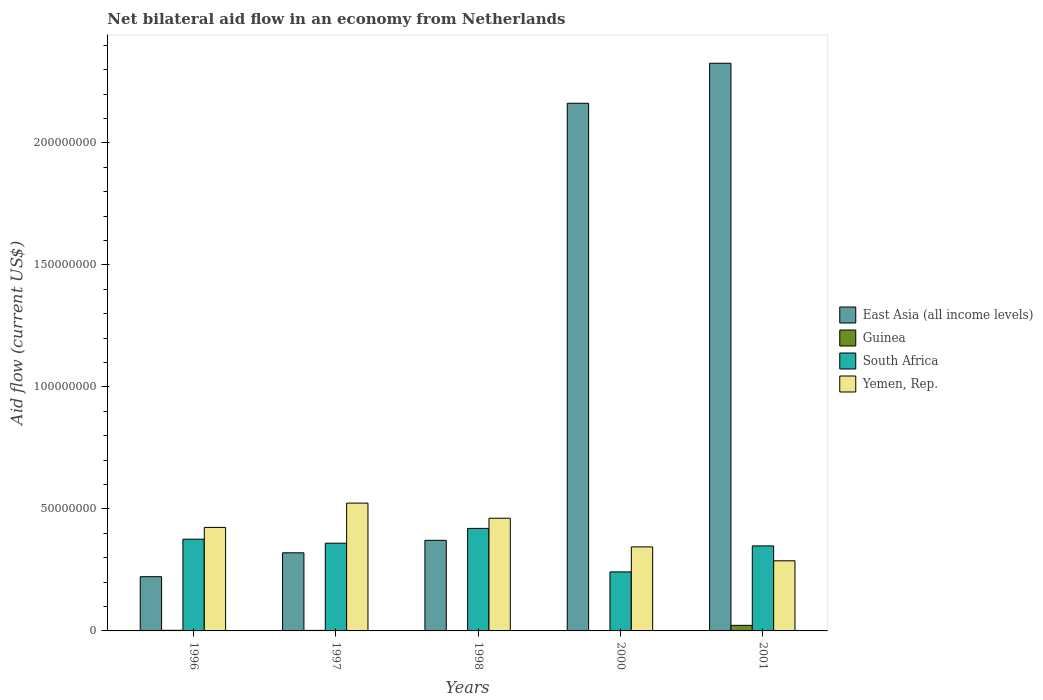Are the number of bars per tick equal to the number of legend labels?
Keep it short and to the point. Yes. How many bars are there on the 3rd tick from the right?
Your answer should be very brief. 4. In how many cases, is the number of bars for a given year not equal to the number of legend labels?
Ensure brevity in your answer.  0. What is the net bilateral aid flow in East Asia (all income levels) in 1998?
Provide a short and direct response. 3.71e+07. Across all years, what is the maximum net bilateral aid flow in South Africa?
Offer a terse response. 4.20e+07. Across all years, what is the minimum net bilateral aid flow in South Africa?
Ensure brevity in your answer.  2.42e+07. In which year was the net bilateral aid flow in South Africa minimum?
Provide a short and direct response. 2000. What is the total net bilateral aid flow in South Africa in the graph?
Your response must be concise. 1.75e+08. What is the difference between the net bilateral aid flow in Guinea in 1998 and that in 2000?
Your answer should be very brief. 7.00e+04. What is the difference between the net bilateral aid flow in Guinea in 2000 and the net bilateral aid flow in Yemen, Rep. in 2001?
Give a very brief answer. -2.87e+07. What is the average net bilateral aid flow in Yemen, Rep. per year?
Provide a short and direct response. 4.08e+07. In the year 2000, what is the difference between the net bilateral aid flow in South Africa and net bilateral aid flow in East Asia (all income levels)?
Keep it short and to the point. -1.92e+08. What is the ratio of the net bilateral aid flow in East Asia (all income levels) in 1998 to that in 2000?
Provide a short and direct response. 0.17. Is the net bilateral aid flow in South Africa in 1996 less than that in 2001?
Keep it short and to the point. No. What is the difference between the highest and the second highest net bilateral aid flow in East Asia (all income levels)?
Offer a terse response. 1.64e+07. What is the difference between the highest and the lowest net bilateral aid flow in South Africa?
Your answer should be very brief. 1.78e+07. In how many years, is the net bilateral aid flow in South Africa greater than the average net bilateral aid flow in South Africa taken over all years?
Provide a succinct answer. 3. Is the sum of the net bilateral aid flow in East Asia (all income levels) in 1998 and 2001 greater than the maximum net bilateral aid flow in Guinea across all years?
Make the answer very short. Yes. What does the 1st bar from the left in 1996 represents?
Provide a succinct answer. East Asia (all income levels). What does the 1st bar from the right in 2001 represents?
Give a very brief answer. Yemen, Rep. Is it the case that in every year, the sum of the net bilateral aid flow in East Asia (all income levels) and net bilateral aid flow in Guinea is greater than the net bilateral aid flow in Yemen, Rep.?
Your answer should be compact. No. Are all the bars in the graph horizontal?
Your answer should be very brief. No. Are the values on the major ticks of Y-axis written in scientific E-notation?
Make the answer very short. No. Does the graph contain any zero values?
Offer a very short reply. No. Where does the legend appear in the graph?
Your answer should be compact. Center right. How many legend labels are there?
Provide a short and direct response. 4. What is the title of the graph?
Offer a very short reply. Net bilateral aid flow in an economy from Netherlands. Does "Italy" appear as one of the legend labels in the graph?
Offer a very short reply. No. What is the label or title of the Y-axis?
Keep it short and to the point. Aid flow (current US$). What is the Aid flow (current US$) in East Asia (all income levels) in 1996?
Make the answer very short. 2.22e+07. What is the Aid flow (current US$) in South Africa in 1996?
Your response must be concise. 3.76e+07. What is the Aid flow (current US$) in Yemen, Rep. in 1996?
Your response must be concise. 4.24e+07. What is the Aid flow (current US$) in East Asia (all income levels) in 1997?
Ensure brevity in your answer.  3.20e+07. What is the Aid flow (current US$) of Guinea in 1997?
Your answer should be compact. 2.20e+05. What is the Aid flow (current US$) in South Africa in 1997?
Ensure brevity in your answer.  3.59e+07. What is the Aid flow (current US$) of Yemen, Rep. in 1997?
Your answer should be very brief. 5.24e+07. What is the Aid flow (current US$) of East Asia (all income levels) in 1998?
Provide a succinct answer. 3.71e+07. What is the Aid flow (current US$) of South Africa in 1998?
Your answer should be compact. 4.20e+07. What is the Aid flow (current US$) in Yemen, Rep. in 1998?
Make the answer very short. 4.62e+07. What is the Aid flow (current US$) of East Asia (all income levels) in 2000?
Offer a terse response. 2.16e+08. What is the Aid flow (current US$) in Guinea in 2000?
Your answer should be compact. 2.00e+04. What is the Aid flow (current US$) in South Africa in 2000?
Ensure brevity in your answer.  2.42e+07. What is the Aid flow (current US$) of Yemen, Rep. in 2000?
Provide a succinct answer. 3.44e+07. What is the Aid flow (current US$) in East Asia (all income levels) in 2001?
Your answer should be compact. 2.33e+08. What is the Aid flow (current US$) in Guinea in 2001?
Keep it short and to the point. 2.28e+06. What is the Aid flow (current US$) of South Africa in 2001?
Give a very brief answer. 3.48e+07. What is the Aid flow (current US$) in Yemen, Rep. in 2001?
Your answer should be very brief. 2.87e+07. Across all years, what is the maximum Aid flow (current US$) in East Asia (all income levels)?
Provide a short and direct response. 2.33e+08. Across all years, what is the maximum Aid flow (current US$) in Guinea?
Give a very brief answer. 2.28e+06. Across all years, what is the maximum Aid flow (current US$) in South Africa?
Give a very brief answer. 4.20e+07. Across all years, what is the maximum Aid flow (current US$) in Yemen, Rep.?
Provide a succinct answer. 5.24e+07. Across all years, what is the minimum Aid flow (current US$) of East Asia (all income levels)?
Ensure brevity in your answer.  2.22e+07. Across all years, what is the minimum Aid flow (current US$) in Guinea?
Offer a very short reply. 2.00e+04. Across all years, what is the minimum Aid flow (current US$) of South Africa?
Offer a very short reply. 2.42e+07. Across all years, what is the minimum Aid flow (current US$) in Yemen, Rep.?
Your answer should be very brief. 2.87e+07. What is the total Aid flow (current US$) in East Asia (all income levels) in the graph?
Provide a succinct answer. 5.40e+08. What is the total Aid flow (current US$) in Guinea in the graph?
Your answer should be compact. 2.86e+06. What is the total Aid flow (current US$) of South Africa in the graph?
Offer a very short reply. 1.75e+08. What is the total Aid flow (current US$) of Yemen, Rep. in the graph?
Provide a short and direct response. 2.04e+08. What is the difference between the Aid flow (current US$) of East Asia (all income levels) in 1996 and that in 1997?
Offer a terse response. -9.79e+06. What is the difference between the Aid flow (current US$) in South Africa in 1996 and that in 1997?
Ensure brevity in your answer.  1.65e+06. What is the difference between the Aid flow (current US$) in Yemen, Rep. in 1996 and that in 1997?
Provide a succinct answer. -9.96e+06. What is the difference between the Aid flow (current US$) of East Asia (all income levels) in 1996 and that in 1998?
Offer a terse response. -1.49e+07. What is the difference between the Aid flow (current US$) in South Africa in 1996 and that in 1998?
Provide a succinct answer. -4.42e+06. What is the difference between the Aid flow (current US$) in Yemen, Rep. in 1996 and that in 1998?
Give a very brief answer. -3.76e+06. What is the difference between the Aid flow (current US$) of East Asia (all income levels) in 1996 and that in 2000?
Offer a very short reply. -1.94e+08. What is the difference between the Aid flow (current US$) in South Africa in 1996 and that in 2000?
Offer a very short reply. 1.34e+07. What is the difference between the Aid flow (current US$) of Yemen, Rep. in 1996 and that in 2000?
Give a very brief answer. 7.99e+06. What is the difference between the Aid flow (current US$) in East Asia (all income levels) in 1996 and that in 2001?
Offer a terse response. -2.10e+08. What is the difference between the Aid flow (current US$) in Guinea in 1996 and that in 2001?
Offer a very short reply. -2.03e+06. What is the difference between the Aid flow (current US$) of South Africa in 1996 and that in 2001?
Your answer should be compact. 2.75e+06. What is the difference between the Aid flow (current US$) of Yemen, Rep. in 1996 and that in 2001?
Give a very brief answer. 1.37e+07. What is the difference between the Aid flow (current US$) in East Asia (all income levels) in 1997 and that in 1998?
Your response must be concise. -5.12e+06. What is the difference between the Aid flow (current US$) in South Africa in 1997 and that in 1998?
Your answer should be very brief. -6.07e+06. What is the difference between the Aid flow (current US$) in Yemen, Rep. in 1997 and that in 1998?
Your response must be concise. 6.20e+06. What is the difference between the Aid flow (current US$) in East Asia (all income levels) in 1997 and that in 2000?
Your answer should be compact. -1.84e+08. What is the difference between the Aid flow (current US$) of Guinea in 1997 and that in 2000?
Provide a short and direct response. 2.00e+05. What is the difference between the Aid flow (current US$) in South Africa in 1997 and that in 2000?
Provide a short and direct response. 1.18e+07. What is the difference between the Aid flow (current US$) in Yemen, Rep. in 1997 and that in 2000?
Your response must be concise. 1.80e+07. What is the difference between the Aid flow (current US$) of East Asia (all income levels) in 1997 and that in 2001?
Offer a terse response. -2.01e+08. What is the difference between the Aid flow (current US$) in Guinea in 1997 and that in 2001?
Ensure brevity in your answer.  -2.06e+06. What is the difference between the Aid flow (current US$) of South Africa in 1997 and that in 2001?
Ensure brevity in your answer.  1.10e+06. What is the difference between the Aid flow (current US$) in Yemen, Rep. in 1997 and that in 2001?
Ensure brevity in your answer.  2.36e+07. What is the difference between the Aid flow (current US$) in East Asia (all income levels) in 1998 and that in 2000?
Keep it short and to the point. -1.79e+08. What is the difference between the Aid flow (current US$) in South Africa in 1998 and that in 2000?
Your answer should be compact. 1.78e+07. What is the difference between the Aid flow (current US$) in Yemen, Rep. in 1998 and that in 2000?
Make the answer very short. 1.18e+07. What is the difference between the Aid flow (current US$) of East Asia (all income levels) in 1998 and that in 2001?
Your answer should be very brief. -1.95e+08. What is the difference between the Aid flow (current US$) in Guinea in 1998 and that in 2001?
Provide a succinct answer. -2.19e+06. What is the difference between the Aid flow (current US$) in South Africa in 1998 and that in 2001?
Your answer should be compact. 7.17e+06. What is the difference between the Aid flow (current US$) in Yemen, Rep. in 1998 and that in 2001?
Make the answer very short. 1.74e+07. What is the difference between the Aid flow (current US$) in East Asia (all income levels) in 2000 and that in 2001?
Your answer should be compact. -1.64e+07. What is the difference between the Aid flow (current US$) in Guinea in 2000 and that in 2001?
Offer a terse response. -2.26e+06. What is the difference between the Aid flow (current US$) in South Africa in 2000 and that in 2001?
Provide a short and direct response. -1.07e+07. What is the difference between the Aid flow (current US$) of Yemen, Rep. in 2000 and that in 2001?
Offer a very short reply. 5.70e+06. What is the difference between the Aid flow (current US$) of East Asia (all income levels) in 1996 and the Aid flow (current US$) of Guinea in 1997?
Offer a very short reply. 2.20e+07. What is the difference between the Aid flow (current US$) of East Asia (all income levels) in 1996 and the Aid flow (current US$) of South Africa in 1997?
Your answer should be compact. -1.37e+07. What is the difference between the Aid flow (current US$) in East Asia (all income levels) in 1996 and the Aid flow (current US$) in Yemen, Rep. in 1997?
Offer a very short reply. -3.02e+07. What is the difference between the Aid flow (current US$) of Guinea in 1996 and the Aid flow (current US$) of South Africa in 1997?
Keep it short and to the point. -3.57e+07. What is the difference between the Aid flow (current US$) of Guinea in 1996 and the Aid flow (current US$) of Yemen, Rep. in 1997?
Keep it short and to the point. -5.21e+07. What is the difference between the Aid flow (current US$) of South Africa in 1996 and the Aid flow (current US$) of Yemen, Rep. in 1997?
Your answer should be compact. -1.48e+07. What is the difference between the Aid flow (current US$) in East Asia (all income levels) in 1996 and the Aid flow (current US$) in Guinea in 1998?
Provide a short and direct response. 2.21e+07. What is the difference between the Aid flow (current US$) in East Asia (all income levels) in 1996 and the Aid flow (current US$) in South Africa in 1998?
Provide a succinct answer. -1.98e+07. What is the difference between the Aid flow (current US$) in East Asia (all income levels) in 1996 and the Aid flow (current US$) in Yemen, Rep. in 1998?
Give a very brief answer. -2.40e+07. What is the difference between the Aid flow (current US$) of Guinea in 1996 and the Aid flow (current US$) of South Africa in 1998?
Your answer should be compact. -4.18e+07. What is the difference between the Aid flow (current US$) in Guinea in 1996 and the Aid flow (current US$) in Yemen, Rep. in 1998?
Your answer should be compact. -4.59e+07. What is the difference between the Aid flow (current US$) of South Africa in 1996 and the Aid flow (current US$) of Yemen, Rep. in 1998?
Ensure brevity in your answer.  -8.59e+06. What is the difference between the Aid flow (current US$) in East Asia (all income levels) in 1996 and the Aid flow (current US$) in Guinea in 2000?
Your response must be concise. 2.22e+07. What is the difference between the Aid flow (current US$) in East Asia (all income levels) in 1996 and the Aid flow (current US$) in South Africa in 2000?
Your answer should be compact. -1.96e+06. What is the difference between the Aid flow (current US$) in East Asia (all income levels) in 1996 and the Aid flow (current US$) in Yemen, Rep. in 2000?
Ensure brevity in your answer.  -1.22e+07. What is the difference between the Aid flow (current US$) of Guinea in 1996 and the Aid flow (current US$) of South Africa in 2000?
Ensure brevity in your answer.  -2.39e+07. What is the difference between the Aid flow (current US$) of Guinea in 1996 and the Aid flow (current US$) of Yemen, Rep. in 2000?
Offer a terse response. -3.42e+07. What is the difference between the Aid flow (current US$) in South Africa in 1996 and the Aid flow (current US$) in Yemen, Rep. in 2000?
Your answer should be compact. 3.16e+06. What is the difference between the Aid flow (current US$) in East Asia (all income levels) in 1996 and the Aid flow (current US$) in Guinea in 2001?
Give a very brief answer. 1.99e+07. What is the difference between the Aid flow (current US$) in East Asia (all income levels) in 1996 and the Aid flow (current US$) in South Africa in 2001?
Your answer should be very brief. -1.26e+07. What is the difference between the Aid flow (current US$) of East Asia (all income levels) in 1996 and the Aid flow (current US$) of Yemen, Rep. in 2001?
Provide a short and direct response. -6.51e+06. What is the difference between the Aid flow (current US$) of Guinea in 1996 and the Aid flow (current US$) of South Africa in 2001?
Provide a short and direct response. -3.46e+07. What is the difference between the Aid flow (current US$) of Guinea in 1996 and the Aid flow (current US$) of Yemen, Rep. in 2001?
Offer a terse response. -2.85e+07. What is the difference between the Aid flow (current US$) in South Africa in 1996 and the Aid flow (current US$) in Yemen, Rep. in 2001?
Provide a succinct answer. 8.86e+06. What is the difference between the Aid flow (current US$) in East Asia (all income levels) in 1997 and the Aid flow (current US$) in Guinea in 1998?
Your answer should be very brief. 3.19e+07. What is the difference between the Aid flow (current US$) of East Asia (all income levels) in 1997 and the Aid flow (current US$) of South Africa in 1998?
Offer a very short reply. -1.00e+07. What is the difference between the Aid flow (current US$) of East Asia (all income levels) in 1997 and the Aid flow (current US$) of Yemen, Rep. in 1998?
Provide a short and direct response. -1.42e+07. What is the difference between the Aid flow (current US$) in Guinea in 1997 and the Aid flow (current US$) in South Africa in 1998?
Provide a short and direct response. -4.18e+07. What is the difference between the Aid flow (current US$) in Guinea in 1997 and the Aid flow (current US$) in Yemen, Rep. in 1998?
Provide a short and direct response. -4.60e+07. What is the difference between the Aid flow (current US$) in South Africa in 1997 and the Aid flow (current US$) in Yemen, Rep. in 1998?
Offer a very short reply. -1.02e+07. What is the difference between the Aid flow (current US$) of East Asia (all income levels) in 1997 and the Aid flow (current US$) of Guinea in 2000?
Give a very brief answer. 3.20e+07. What is the difference between the Aid flow (current US$) of East Asia (all income levels) in 1997 and the Aid flow (current US$) of South Africa in 2000?
Make the answer very short. 7.83e+06. What is the difference between the Aid flow (current US$) in East Asia (all income levels) in 1997 and the Aid flow (current US$) in Yemen, Rep. in 2000?
Ensure brevity in your answer.  -2.42e+06. What is the difference between the Aid flow (current US$) in Guinea in 1997 and the Aid flow (current US$) in South Africa in 2000?
Give a very brief answer. -2.40e+07. What is the difference between the Aid flow (current US$) of Guinea in 1997 and the Aid flow (current US$) of Yemen, Rep. in 2000?
Your answer should be very brief. -3.42e+07. What is the difference between the Aid flow (current US$) of South Africa in 1997 and the Aid flow (current US$) of Yemen, Rep. in 2000?
Your answer should be very brief. 1.51e+06. What is the difference between the Aid flow (current US$) in East Asia (all income levels) in 1997 and the Aid flow (current US$) in Guinea in 2001?
Give a very brief answer. 2.97e+07. What is the difference between the Aid flow (current US$) in East Asia (all income levels) in 1997 and the Aid flow (current US$) in South Africa in 2001?
Your answer should be very brief. -2.83e+06. What is the difference between the Aid flow (current US$) in East Asia (all income levels) in 1997 and the Aid flow (current US$) in Yemen, Rep. in 2001?
Give a very brief answer. 3.28e+06. What is the difference between the Aid flow (current US$) in Guinea in 1997 and the Aid flow (current US$) in South Africa in 2001?
Offer a very short reply. -3.46e+07. What is the difference between the Aid flow (current US$) of Guinea in 1997 and the Aid flow (current US$) of Yemen, Rep. in 2001?
Your answer should be very brief. -2.85e+07. What is the difference between the Aid flow (current US$) of South Africa in 1997 and the Aid flow (current US$) of Yemen, Rep. in 2001?
Provide a short and direct response. 7.21e+06. What is the difference between the Aid flow (current US$) in East Asia (all income levels) in 1998 and the Aid flow (current US$) in Guinea in 2000?
Offer a terse response. 3.71e+07. What is the difference between the Aid flow (current US$) in East Asia (all income levels) in 1998 and the Aid flow (current US$) in South Africa in 2000?
Your answer should be compact. 1.30e+07. What is the difference between the Aid flow (current US$) in East Asia (all income levels) in 1998 and the Aid flow (current US$) in Yemen, Rep. in 2000?
Your answer should be very brief. 2.70e+06. What is the difference between the Aid flow (current US$) of Guinea in 1998 and the Aid flow (current US$) of South Africa in 2000?
Offer a very short reply. -2.41e+07. What is the difference between the Aid flow (current US$) in Guinea in 1998 and the Aid flow (current US$) in Yemen, Rep. in 2000?
Offer a terse response. -3.43e+07. What is the difference between the Aid flow (current US$) of South Africa in 1998 and the Aid flow (current US$) of Yemen, Rep. in 2000?
Provide a succinct answer. 7.58e+06. What is the difference between the Aid flow (current US$) in East Asia (all income levels) in 1998 and the Aid flow (current US$) in Guinea in 2001?
Your answer should be compact. 3.48e+07. What is the difference between the Aid flow (current US$) in East Asia (all income levels) in 1998 and the Aid flow (current US$) in South Africa in 2001?
Your response must be concise. 2.29e+06. What is the difference between the Aid flow (current US$) in East Asia (all income levels) in 1998 and the Aid flow (current US$) in Yemen, Rep. in 2001?
Your answer should be compact. 8.40e+06. What is the difference between the Aid flow (current US$) of Guinea in 1998 and the Aid flow (current US$) of South Africa in 2001?
Your answer should be compact. -3.48e+07. What is the difference between the Aid flow (current US$) in Guinea in 1998 and the Aid flow (current US$) in Yemen, Rep. in 2001?
Your answer should be compact. -2.86e+07. What is the difference between the Aid flow (current US$) of South Africa in 1998 and the Aid flow (current US$) of Yemen, Rep. in 2001?
Make the answer very short. 1.33e+07. What is the difference between the Aid flow (current US$) of East Asia (all income levels) in 2000 and the Aid flow (current US$) of Guinea in 2001?
Your answer should be very brief. 2.14e+08. What is the difference between the Aid flow (current US$) in East Asia (all income levels) in 2000 and the Aid flow (current US$) in South Africa in 2001?
Provide a succinct answer. 1.81e+08. What is the difference between the Aid flow (current US$) in East Asia (all income levels) in 2000 and the Aid flow (current US$) in Yemen, Rep. in 2001?
Make the answer very short. 1.88e+08. What is the difference between the Aid flow (current US$) of Guinea in 2000 and the Aid flow (current US$) of South Africa in 2001?
Give a very brief answer. -3.48e+07. What is the difference between the Aid flow (current US$) in Guinea in 2000 and the Aid flow (current US$) in Yemen, Rep. in 2001?
Ensure brevity in your answer.  -2.87e+07. What is the difference between the Aid flow (current US$) of South Africa in 2000 and the Aid flow (current US$) of Yemen, Rep. in 2001?
Offer a terse response. -4.55e+06. What is the average Aid flow (current US$) in East Asia (all income levels) per year?
Provide a short and direct response. 1.08e+08. What is the average Aid flow (current US$) of Guinea per year?
Give a very brief answer. 5.72e+05. What is the average Aid flow (current US$) of South Africa per year?
Offer a very short reply. 3.49e+07. What is the average Aid flow (current US$) of Yemen, Rep. per year?
Offer a terse response. 4.08e+07. In the year 1996, what is the difference between the Aid flow (current US$) of East Asia (all income levels) and Aid flow (current US$) of Guinea?
Provide a succinct answer. 2.20e+07. In the year 1996, what is the difference between the Aid flow (current US$) in East Asia (all income levels) and Aid flow (current US$) in South Africa?
Your response must be concise. -1.54e+07. In the year 1996, what is the difference between the Aid flow (current US$) in East Asia (all income levels) and Aid flow (current US$) in Yemen, Rep.?
Your response must be concise. -2.02e+07. In the year 1996, what is the difference between the Aid flow (current US$) of Guinea and Aid flow (current US$) of South Africa?
Offer a very short reply. -3.73e+07. In the year 1996, what is the difference between the Aid flow (current US$) in Guinea and Aid flow (current US$) in Yemen, Rep.?
Offer a very short reply. -4.22e+07. In the year 1996, what is the difference between the Aid flow (current US$) in South Africa and Aid flow (current US$) in Yemen, Rep.?
Provide a short and direct response. -4.83e+06. In the year 1997, what is the difference between the Aid flow (current US$) of East Asia (all income levels) and Aid flow (current US$) of Guinea?
Make the answer very short. 3.18e+07. In the year 1997, what is the difference between the Aid flow (current US$) of East Asia (all income levels) and Aid flow (current US$) of South Africa?
Your answer should be compact. -3.93e+06. In the year 1997, what is the difference between the Aid flow (current US$) in East Asia (all income levels) and Aid flow (current US$) in Yemen, Rep.?
Provide a short and direct response. -2.04e+07. In the year 1997, what is the difference between the Aid flow (current US$) of Guinea and Aid flow (current US$) of South Africa?
Your answer should be very brief. -3.57e+07. In the year 1997, what is the difference between the Aid flow (current US$) of Guinea and Aid flow (current US$) of Yemen, Rep.?
Your answer should be compact. -5.22e+07. In the year 1997, what is the difference between the Aid flow (current US$) in South Africa and Aid flow (current US$) in Yemen, Rep.?
Keep it short and to the point. -1.64e+07. In the year 1998, what is the difference between the Aid flow (current US$) in East Asia (all income levels) and Aid flow (current US$) in Guinea?
Make the answer very short. 3.70e+07. In the year 1998, what is the difference between the Aid flow (current US$) of East Asia (all income levels) and Aid flow (current US$) of South Africa?
Provide a short and direct response. -4.88e+06. In the year 1998, what is the difference between the Aid flow (current US$) in East Asia (all income levels) and Aid flow (current US$) in Yemen, Rep.?
Offer a terse response. -9.05e+06. In the year 1998, what is the difference between the Aid flow (current US$) in Guinea and Aid flow (current US$) in South Africa?
Your answer should be compact. -4.19e+07. In the year 1998, what is the difference between the Aid flow (current US$) of Guinea and Aid flow (current US$) of Yemen, Rep.?
Provide a short and direct response. -4.61e+07. In the year 1998, what is the difference between the Aid flow (current US$) in South Africa and Aid flow (current US$) in Yemen, Rep.?
Keep it short and to the point. -4.17e+06. In the year 2000, what is the difference between the Aid flow (current US$) in East Asia (all income levels) and Aid flow (current US$) in Guinea?
Offer a terse response. 2.16e+08. In the year 2000, what is the difference between the Aid flow (current US$) in East Asia (all income levels) and Aid flow (current US$) in South Africa?
Your response must be concise. 1.92e+08. In the year 2000, what is the difference between the Aid flow (current US$) of East Asia (all income levels) and Aid flow (current US$) of Yemen, Rep.?
Provide a short and direct response. 1.82e+08. In the year 2000, what is the difference between the Aid flow (current US$) of Guinea and Aid flow (current US$) of South Africa?
Offer a terse response. -2.42e+07. In the year 2000, what is the difference between the Aid flow (current US$) of Guinea and Aid flow (current US$) of Yemen, Rep.?
Your answer should be very brief. -3.44e+07. In the year 2000, what is the difference between the Aid flow (current US$) in South Africa and Aid flow (current US$) in Yemen, Rep.?
Provide a succinct answer. -1.02e+07. In the year 2001, what is the difference between the Aid flow (current US$) of East Asia (all income levels) and Aid flow (current US$) of Guinea?
Keep it short and to the point. 2.30e+08. In the year 2001, what is the difference between the Aid flow (current US$) in East Asia (all income levels) and Aid flow (current US$) in South Africa?
Make the answer very short. 1.98e+08. In the year 2001, what is the difference between the Aid flow (current US$) in East Asia (all income levels) and Aid flow (current US$) in Yemen, Rep.?
Your answer should be compact. 2.04e+08. In the year 2001, what is the difference between the Aid flow (current US$) of Guinea and Aid flow (current US$) of South Africa?
Provide a succinct answer. -3.26e+07. In the year 2001, what is the difference between the Aid flow (current US$) of Guinea and Aid flow (current US$) of Yemen, Rep.?
Your answer should be very brief. -2.64e+07. In the year 2001, what is the difference between the Aid flow (current US$) in South Africa and Aid flow (current US$) in Yemen, Rep.?
Offer a terse response. 6.11e+06. What is the ratio of the Aid flow (current US$) in East Asia (all income levels) in 1996 to that in 1997?
Offer a terse response. 0.69. What is the ratio of the Aid flow (current US$) of Guinea in 1996 to that in 1997?
Keep it short and to the point. 1.14. What is the ratio of the Aid flow (current US$) in South Africa in 1996 to that in 1997?
Provide a succinct answer. 1.05. What is the ratio of the Aid flow (current US$) of Yemen, Rep. in 1996 to that in 1997?
Give a very brief answer. 0.81. What is the ratio of the Aid flow (current US$) in East Asia (all income levels) in 1996 to that in 1998?
Provide a succinct answer. 0.6. What is the ratio of the Aid flow (current US$) of Guinea in 1996 to that in 1998?
Offer a terse response. 2.78. What is the ratio of the Aid flow (current US$) of South Africa in 1996 to that in 1998?
Provide a succinct answer. 0.89. What is the ratio of the Aid flow (current US$) in Yemen, Rep. in 1996 to that in 1998?
Provide a short and direct response. 0.92. What is the ratio of the Aid flow (current US$) of East Asia (all income levels) in 1996 to that in 2000?
Give a very brief answer. 0.1. What is the ratio of the Aid flow (current US$) in South Africa in 1996 to that in 2000?
Your answer should be very brief. 1.55. What is the ratio of the Aid flow (current US$) of Yemen, Rep. in 1996 to that in 2000?
Offer a terse response. 1.23. What is the ratio of the Aid flow (current US$) of East Asia (all income levels) in 1996 to that in 2001?
Make the answer very short. 0.1. What is the ratio of the Aid flow (current US$) in Guinea in 1996 to that in 2001?
Provide a short and direct response. 0.11. What is the ratio of the Aid flow (current US$) in South Africa in 1996 to that in 2001?
Keep it short and to the point. 1.08. What is the ratio of the Aid flow (current US$) of Yemen, Rep. in 1996 to that in 2001?
Offer a terse response. 1.48. What is the ratio of the Aid flow (current US$) in East Asia (all income levels) in 1997 to that in 1998?
Your answer should be compact. 0.86. What is the ratio of the Aid flow (current US$) of Guinea in 1997 to that in 1998?
Your answer should be compact. 2.44. What is the ratio of the Aid flow (current US$) of South Africa in 1997 to that in 1998?
Ensure brevity in your answer.  0.86. What is the ratio of the Aid flow (current US$) of Yemen, Rep. in 1997 to that in 1998?
Give a very brief answer. 1.13. What is the ratio of the Aid flow (current US$) of East Asia (all income levels) in 1997 to that in 2000?
Provide a short and direct response. 0.15. What is the ratio of the Aid flow (current US$) in Guinea in 1997 to that in 2000?
Your answer should be very brief. 11. What is the ratio of the Aid flow (current US$) in South Africa in 1997 to that in 2000?
Offer a terse response. 1.49. What is the ratio of the Aid flow (current US$) in Yemen, Rep. in 1997 to that in 2000?
Give a very brief answer. 1.52. What is the ratio of the Aid flow (current US$) in East Asia (all income levels) in 1997 to that in 2001?
Keep it short and to the point. 0.14. What is the ratio of the Aid flow (current US$) of Guinea in 1997 to that in 2001?
Your answer should be compact. 0.1. What is the ratio of the Aid flow (current US$) in South Africa in 1997 to that in 2001?
Offer a very short reply. 1.03. What is the ratio of the Aid flow (current US$) in Yemen, Rep. in 1997 to that in 2001?
Provide a succinct answer. 1.82. What is the ratio of the Aid flow (current US$) in East Asia (all income levels) in 1998 to that in 2000?
Your answer should be compact. 0.17. What is the ratio of the Aid flow (current US$) in South Africa in 1998 to that in 2000?
Provide a succinct answer. 1.74. What is the ratio of the Aid flow (current US$) in Yemen, Rep. in 1998 to that in 2000?
Provide a short and direct response. 1.34. What is the ratio of the Aid flow (current US$) of East Asia (all income levels) in 1998 to that in 2001?
Give a very brief answer. 0.16. What is the ratio of the Aid flow (current US$) in Guinea in 1998 to that in 2001?
Offer a very short reply. 0.04. What is the ratio of the Aid flow (current US$) of South Africa in 1998 to that in 2001?
Provide a short and direct response. 1.21. What is the ratio of the Aid flow (current US$) in Yemen, Rep. in 1998 to that in 2001?
Your answer should be compact. 1.61. What is the ratio of the Aid flow (current US$) of East Asia (all income levels) in 2000 to that in 2001?
Ensure brevity in your answer.  0.93. What is the ratio of the Aid flow (current US$) of Guinea in 2000 to that in 2001?
Give a very brief answer. 0.01. What is the ratio of the Aid flow (current US$) of South Africa in 2000 to that in 2001?
Offer a very short reply. 0.69. What is the ratio of the Aid flow (current US$) of Yemen, Rep. in 2000 to that in 2001?
Your answer should be compact. 1.2. What is the difference between the highest and the second highest Aid flow (current US$) in East Asia (all income levels)?
Give a very brief answer. 1.64e+07. What is the difference between the highest and the second highest Aid flow (current US$) of Guinea?
Your answer should be compact. 2.03e+06. What is the difference between the highest and the second highest Aid flow (current US$) in South Africa?
Make the answer very short. 4.42e+06. What is the difference between the highest and the second highest Aid flow (current US$) of Yemen, Rep.?
Your answer should be compact. 6.20e+06. What is the difference between the highest and the lowest Aid flow (current US$) in East Asia (all income levels)?
Ensure brevity in your answer.  2.10e+08. What is the difference between the highest and the lowest Aid flow (current US$) in Guinea?
Offer a very short reply. 2.26e+06. What is the difference between the highest and the lowest Aid flow (current US$) of South Africa?
Your answer should be very brief. 1.78e+07. What is the difference between the highest and the lowest Aid flow (current US$) of Yemen, Rep.?
Your answer should be very brief. 2.36e+07. 